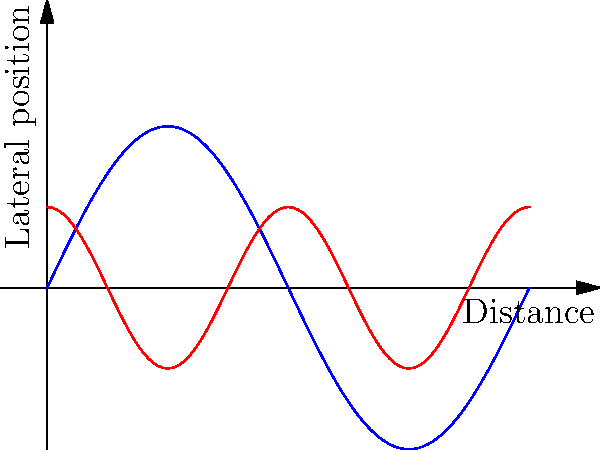In a NASCAR race, two cars are approaching a turn using different trajectories represented by sine and cosine waves. Car A's path is given by $y_A = 0.5\sin(x)$, while Car B's path is given by $y_B = 0.25\cos(2x)$, where $x$ represents the distance along the track and $y$ represents the lateral position. At what distance $x$ (in radians) do the cars have the same lateral position for the first time, allowing for a potential overtaking maneuver? To find where the cars have the same lateral position, we need to solve the equation:

$$ 0.5\sin(x) = 0.25\cos(2x) $$

Let's solve this step-by-step:

1) First, multiply both sides by 2 to simplify:
   $$ \sin(x) = 0.5\cos(2x) $$

2) Use the double angle formula for cosine: $\cos(2x) = 1 - 2\sin^2(x)$
   $$ \sin(x) = 0.5(1 - 2\sin^2(x)) $$

3) Expand the right side:
   $$ \sin(x) = 0.5 - \sin^2(x) $$

4) Rearrange the equation:
   $$ \sin^2(x) + \sin(x) - 0.5 = 0 $$

5) This is a quadratic equation in $\sin(x)$. Use the quadratic formula:
   $$ \sin(x) = \frac{-1 \pm \sqrt{1^2 - 4(1)(-0.5)}}{2(1)} = \frac{-1 \pm \sqrt{3}}{2} $$

6) We're interested in the positive solution (as we're looking for the first intersection):
   $$ \sin(x) = \frac{-1 + \sqrt{3}}{2} $$

7) Take the arcsine of both sides:
   $$ x = \arcsin(\frac{-1 + \sqrt{3}}{2}) \approx 0.5236 \text{ radians} $$

This is the first point where the two trajectories intersect, allowing for a potential overtaking maneuver.
Answer: $0.5236$ radians 